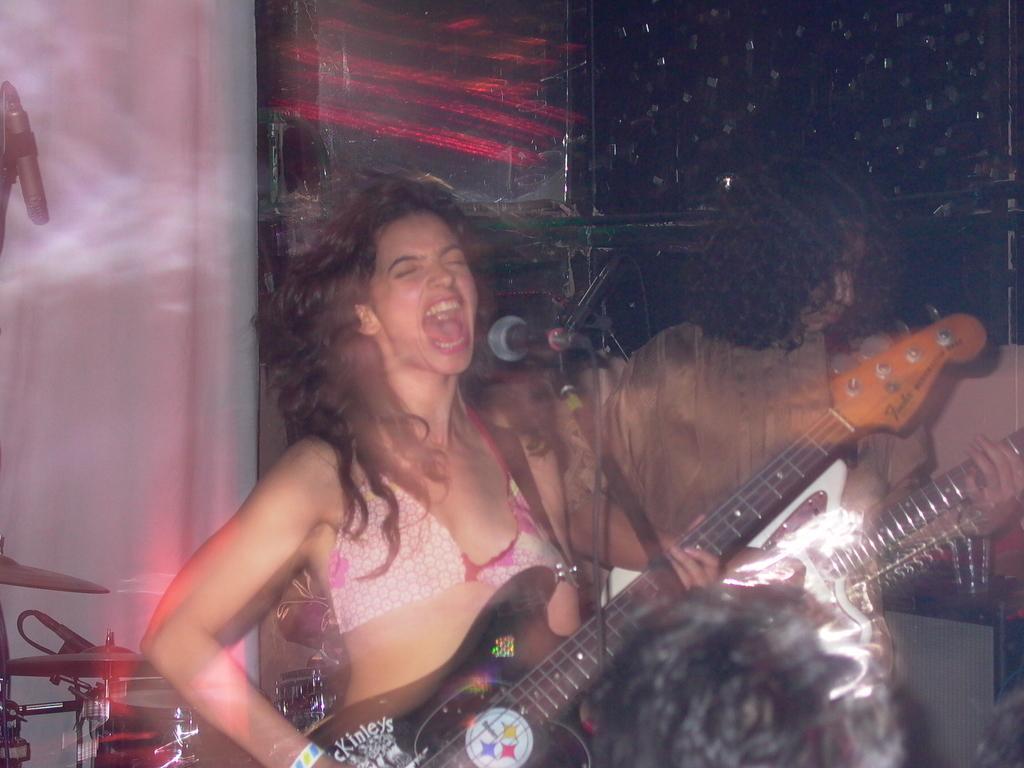How would you summarize this image in a sentence or two? A woman is singing on mic and playing guitar,behind her a person is playing guitar and there are musical instruments. 